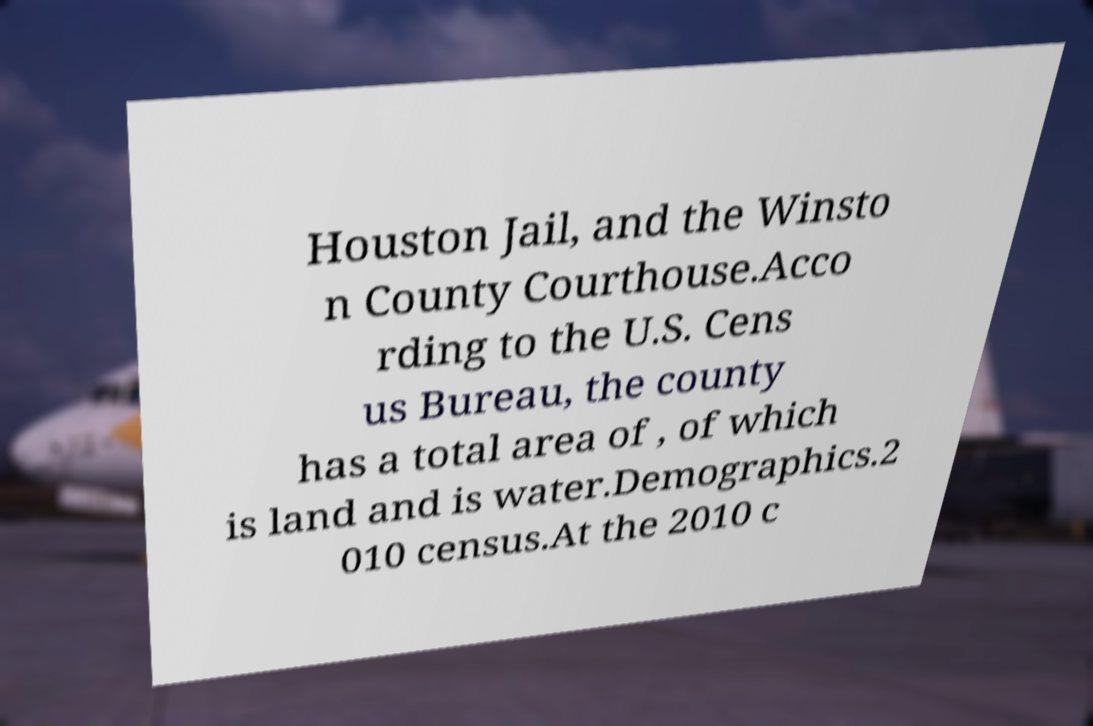Can you read and provide the text displayed in the image?This photo seems to have some interesting text. Can you extract and type it out for me? Houston Jail, and the Winsto n County Courthouse.Acco rding to the U.S. Cens us Bureau, the county has a total area of , of which is land and is water.Demographics.2 010 census.At the 2010 c 